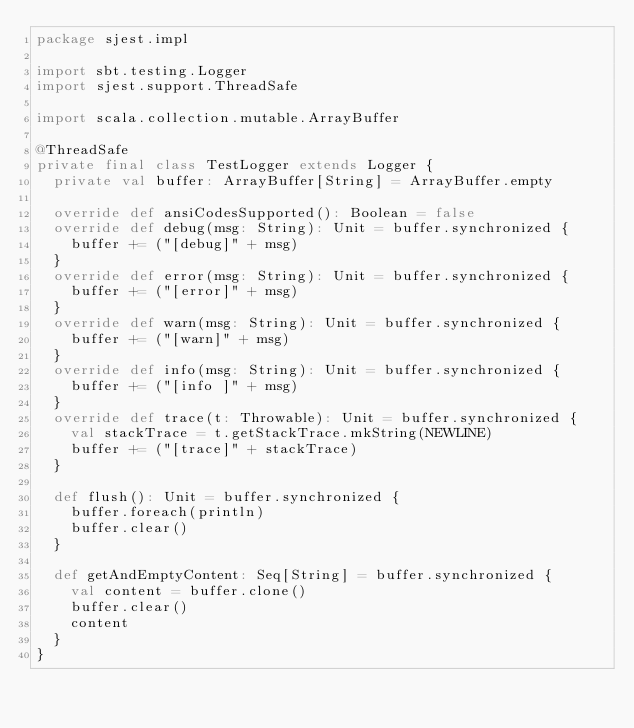<code> <loc_0><loc_0><loc_500><loc_500><_Scala_>package sjest.impl

import sbt.testing.Logger
import sjest.support.ThreadSafe

import scala.collection.mutable.ArrayBuffer

@ThreadSafe
private final class TestLogger extends Logger {
  private val buffer: ArrayBuffer[String] = ArrayBuffer.empty

  override def ansiCodesSupported(): Boolean = false
  override def debug(msg: String): Unit = buffer.synchronized {
    buffer += ("[debug]" + msg)
  }
  override def error(msg: String): Unit = buffer.synchronized {
    buffer += ("[error]" + msg)
  }
  override def warn(msg: String): Unit = buffer.synchronized {
    buffer += ("[warn]" + msg)
  }
  override def info(msg: String): Unit = buffer.synchronized {
    buffer += ("[info ]" + msg)
  }
  override def trace(t: Throwable): Unit = buffer.synchronized {
    val stackTrace = t.getStackTrace.mkString(NEWLINE)
    buffer += ("[trace]" + stackTrace)
  }

  def flush(): Unit = buffer.synchronized {
    buffer.foreach(println)
    buffer.clear()
  }

  def getAndEmptyContent: Seq[String] = buffer.synchronized {
    val content = buffer.clone()
    buffer.clear()
    content
  }
}
</code> 